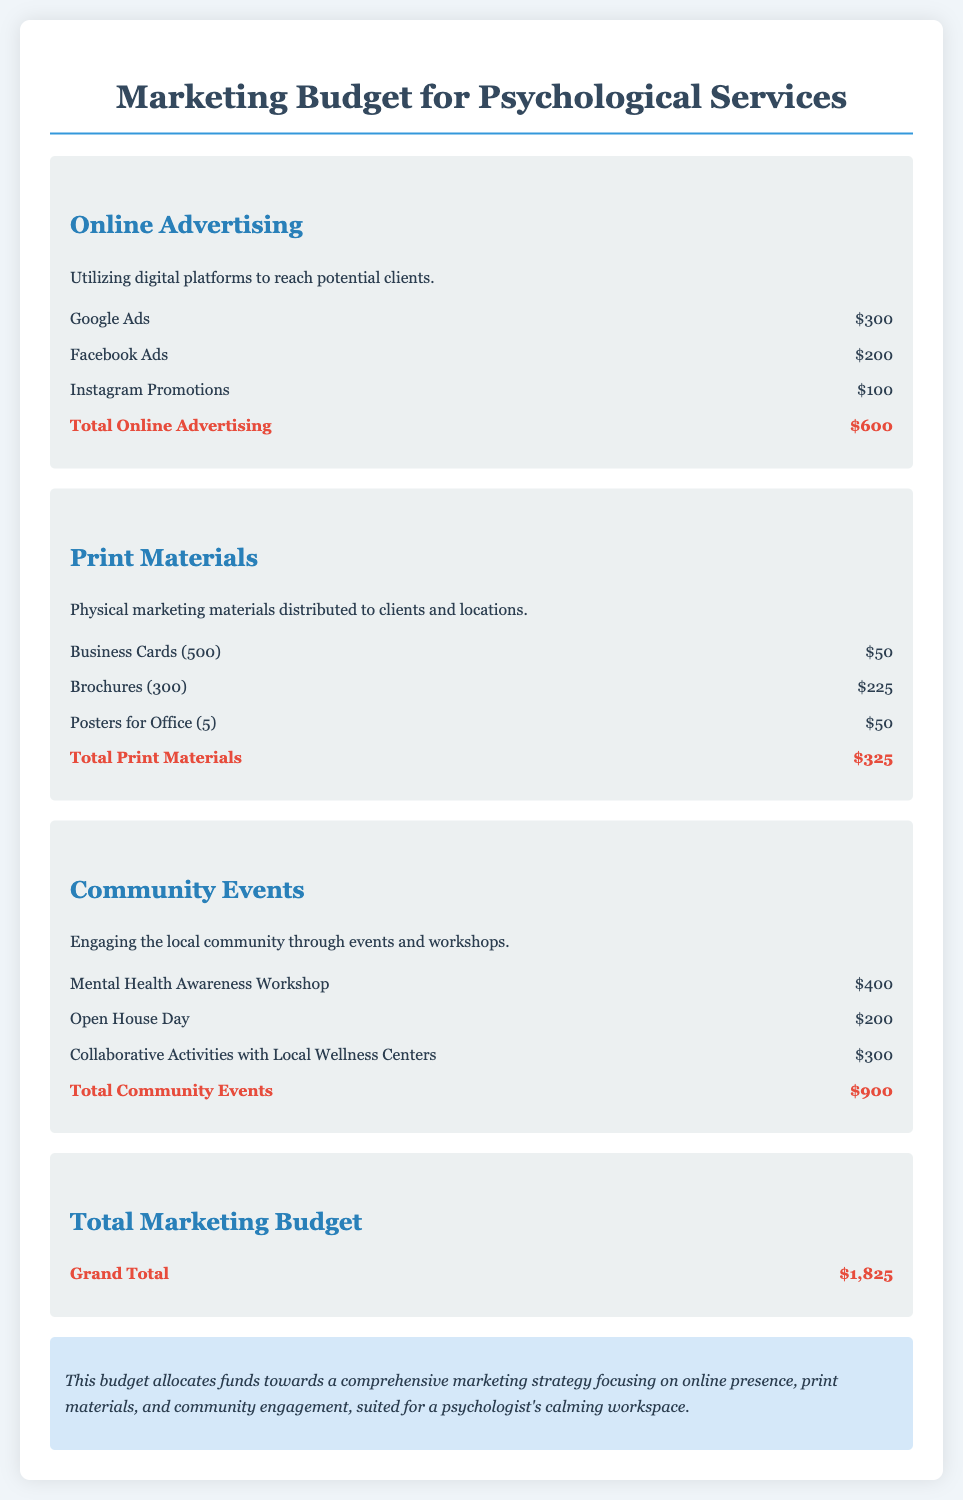What is the total amount allocated for online advertising? The total for online advertising is provided in the document under the relevant section, which sums to $600.
Answer: $600 How much is spent on business cards? The budget for business cards is listed specifically, which is $50.
Answer: $50 What is the total budget for community events? The section on community events lists the total amount spent, which adds up to $900.
Answer: $900 What are the total print materials expenses? The document mentions the total for print materials, which is $325.
Answer: $325 What is the grand total for the marketing budget? The grand total is given at the end of the budget summary, which sums to $1,825.
Answer: $1,825 Which advertising platform has the highest budget allocation? Comparing the different advertising line items, Google Ads has the highest allocation of $300.
Answer: Google Ads What event has the highest cost in the community events section? The budget outlines that the Mental Health Awareness Workshop costs $400, making it the highest in that section.
Answer: $400 What type of materials are included in the print category? The print materials category includes business cards, brochures, and posters.
Answer: Business cards, brochures, and posters What is the purpose of the community events line item in the budget? The phrase under the community events section explains that these funds engage the local community through events and workshops.
Answer: Engaging the local community through events and workshops 